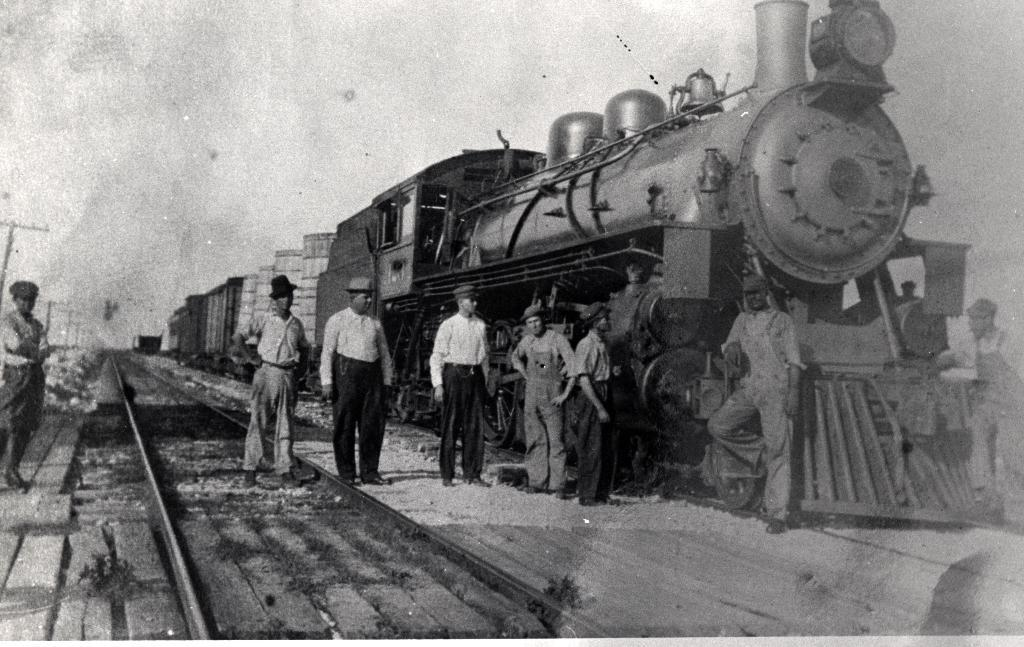What is the main subject of the picture? The main subject of the picture is an old image of a train engine. Are there any people present in the image? Yes, there is a group of workers standing in front of the train engine. What are the workers doing in the image? The workers are looking at the camera. What can be seen on the left side of the image? There is a train track on the left side of the image. What type of meal is being prepared by the workers in the image? There is no indication of a meal being prepared in the image; the workers are standing in front of a train engine and looking at the camera. 